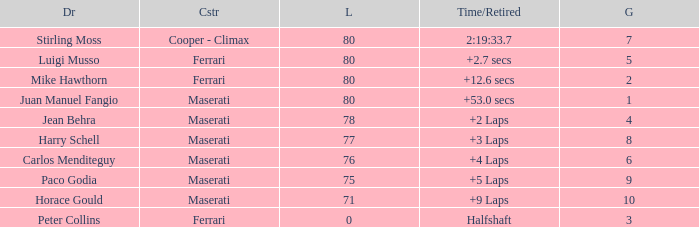What were the lowest laps of Luigi Musso driving a Ferrari with a Grid larger than 2? 80.0. 